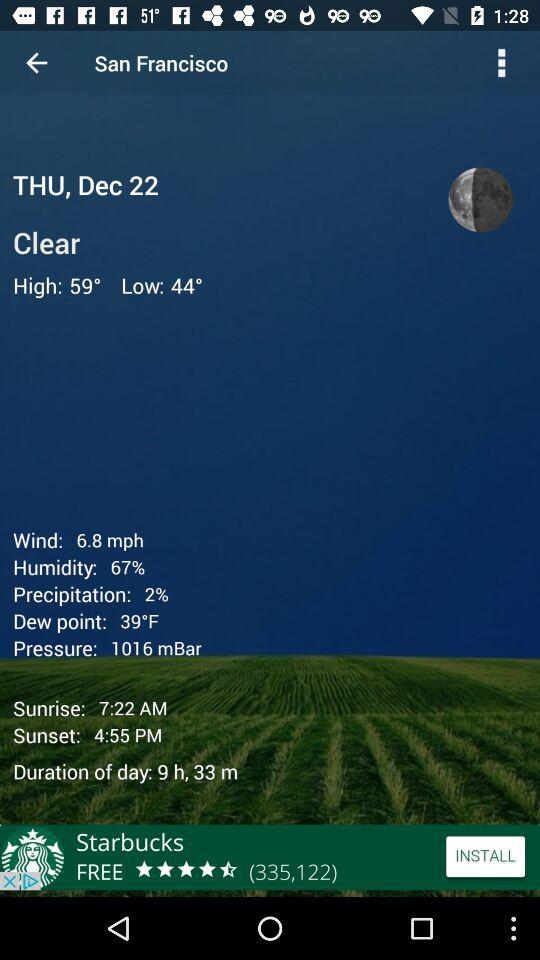What is the dew point? The dew point is 39 °F. 